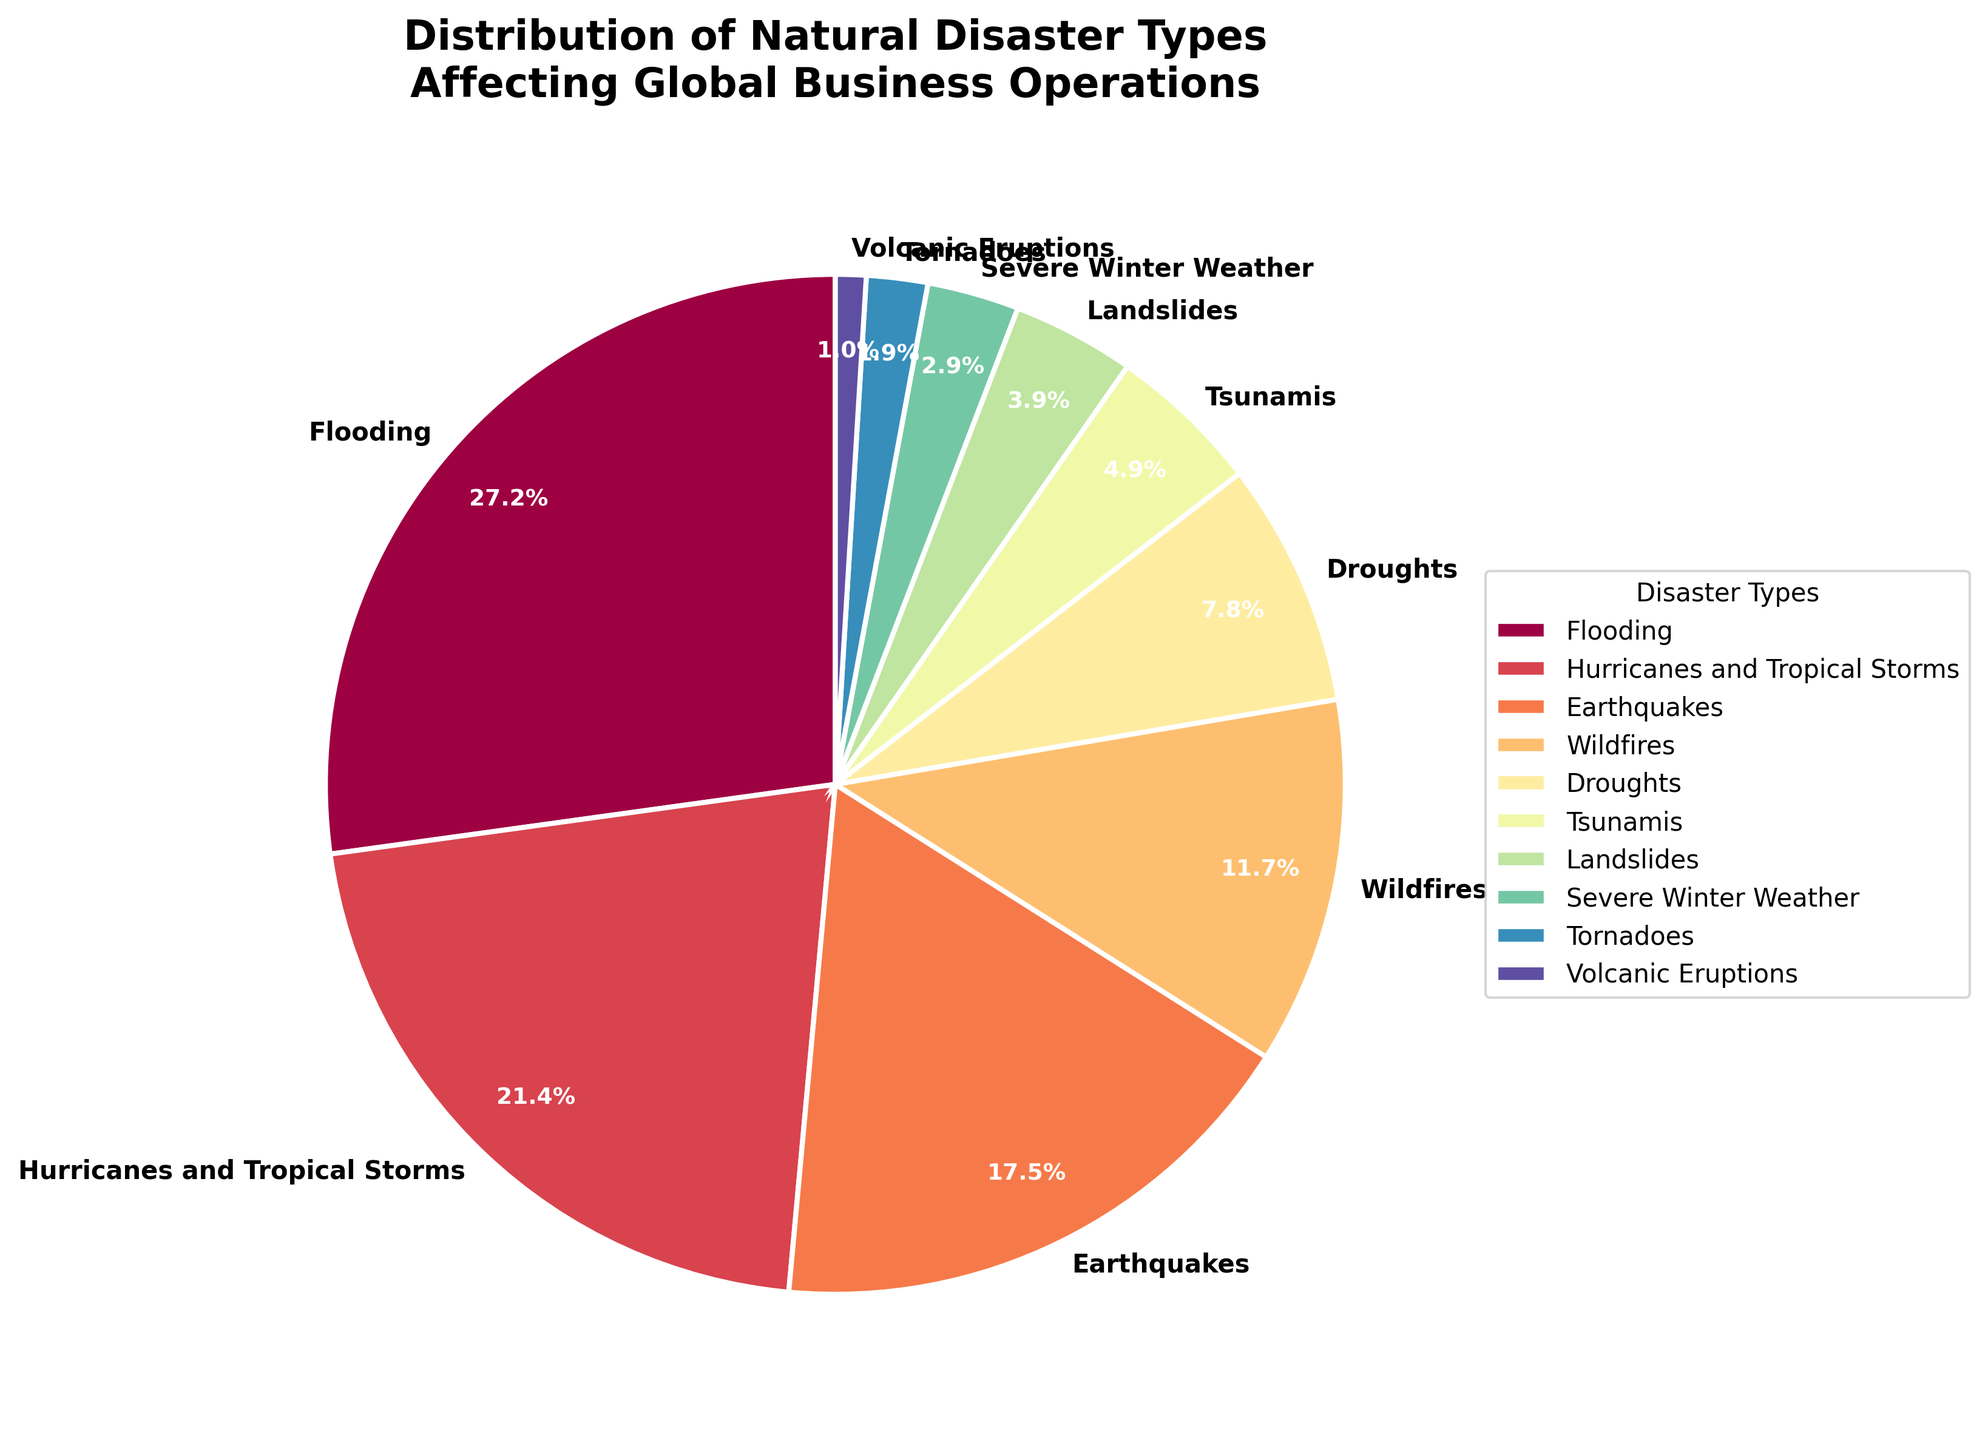Which natural disaster type has the largest impact on global business operations according to the chart? The pie chart shows that the largest segment is labeled "Flooding" with a percentage of 28%.
Answer: Flooding Which two disaster types combined account for nearly half of the impact on global business operations? From the pie chart, the largest segments are "Flooding" at 28% and "Hurricanes and Tropical Storms" at 22%. Their combined percentage is 28% + 22% = 50%.
Answer: Flooding and Hurricanes and Tropical Storms What is the total percentage for wildfire, droughts, and landslides combined? Adding the percentages of "Wildfires" (12%), "Droughts" (8%), and "Landslides" (4%) gives 12% + 8% + 4% = 24%.
Answer: 24% How does the impact of severe winter weather compare to that of tornadoes? The pie chart indicates that "Severe Winter Weather" accounts for 3% and "Tornadoes" account for 2%. This means severe winter weather has a 1% greater impact than tornadoes.
Answer: 1% greater Which disaster type has the smallest impact on global business operations, and what is its percentage? The smallest segment in the pie chart is "Volcanic Eruptions" with a percentage of 1%.
Answer: Volcanic Eruptions, 1% What is the difference in impact between earthquakes and tsunamis? The pie chart shows "Earthquakes" at 18% and "Tsunamis" at 5%. The difference is 18% - 5% = 13%.
Answer: 13% Which three disaster types together have the least impact and what is their combined percentage? The three smallest segments are "Volcanic Eruptions" (1%), "Tornadoes" (2%), and "Severe Winter Weather" (3%). Their combined percentage is 1% + 2% + 3% = 6%.
Answer: Volcanic Eruptions, Tornadoes, and Severe Winter Weather, 6% Which colors are used for the largest and smallest segments in the pie chart? The largest segment, "Flooding," is colored using the first color in the colormap, and the smallest segment, "Volcanic Eruptions," uses the last color in the colormap.
Answer: First and last colors of the colormap If we combine the impact percentages of hurricanes, wildfires, and droughts, is it greater than that of flooding? Adding the percentages of "Hurricanes and Tropical Storms" (22%), "Wildfires" (12%), and "Droughts" (8%) gives a total of 22% + 12% + 8% = 42%, which is greater than "Flooding" at 28%.
Answer: Yes, 42% is greater than 28% What is the average impact percentage of the disaster types listed in the pie chart? To find the average, sum all percentages: 28% + 22% + 18% + 12% + 8% + 5% + 4% + 3% + 2% + 1% = 103%. Then divide by the number of disaster types, which is 10. So the average is 103/10 = 10.3%.
Answer: 10.3% 